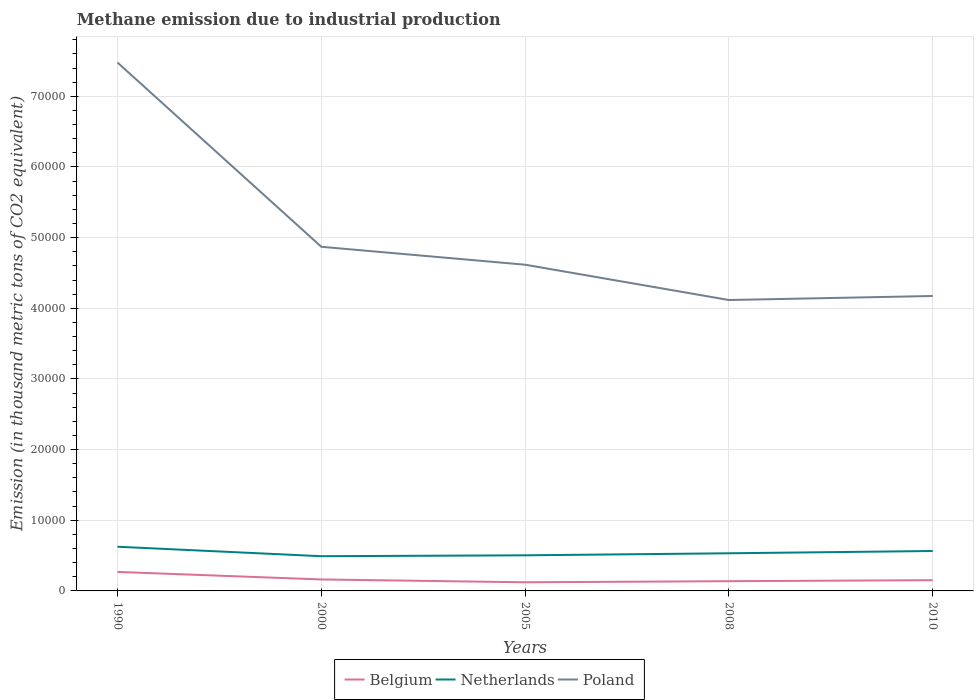How many different coloured lines are there?
Your response must be concise. 3. Does the line corresponding to Poland intersect with the line corresponding to Belgium?
Offer a very short reply. No. Is the number of lines equal to the number of legend labels?
Your answer should be compact. Yes. Across all years, what is the maximum amount of methane emitted in Poland?
Provide a succinct answer. 4.12e+04. What is the total amount of methane emitted in Belgium in the graph?
Make the answer very short. 400.3. What is the difference between the highest and the second highest amount of methane emitted in Belgium?
Make the answer very short. 1465.5. Is the amount of methane emitted in Netherlands strictly greater than the amount of methane emitted in Belgium over the years?
Your answer should be compact. No. How many lines are there?
Your answer should be compact. 3. How many years are there in the graph?
Ensure brevity in your answer.  5. What is the difference between two consecutive major ticks on the Y-axis?
Ensure brevity in your answer.  10000. Are the values on the major ticks of Y-axis written in scientific E-notation?
Offer a terse response. No. Does the graph contain any zero values?
Your answer should be very brief. No. Where does the legend appear in the graph?
Your answer should be very brief. Bottom center. How are the legend labels stacked?
Your answer should be compact. Horizontal. What is the title of the graph?
Make the answer very short. Methane emission due to industrial production. What is the label or title of the X-axis?
Provide a succinct answer. Years. What is the label or title of the Y-axis?
Ensure brevity in your answer.  Emission (in thousand metric tons of CO2 equivalent). What is the Emission (in thousand metric tons of CO2 equivalent) of Belgium in 1990?
Your answer should be very brief. 2688.2. What is the Emission (in thousand metric tons of CO2 equivalent) of Netherlands in 1990?
Your answer should be very brief. 6254.4. What is the Emission (in thousand metric tons of CO2 equivalent) in Poland in 1990?
Your answer should be very brief. 7.48e+04. What is the Emission (in thousand metric tons of CO2 equivalent) of Belgium in 2000?
Give a very brief answer. 1623. What is the Emission (in thousand metric tons of CO2 equivalent) of Netherlands in 2000?
Your answer should be compact. 4913.4. What is the Emission (in thousand metric tons of CO2 equivalent) in Poland in 2000?
Keep it short and to the point. 4.87e+04. What is the Emission (in thousand metric tons of CO2 equivalent) of Belgium in 2005?
Your response must be concise. 1222.7. What is the Emission (in thousand metric tons of CO2 equivalent) of Netherlands in 2005?
Give a very brief answer. 5039.5. What is the Emission (in thousand metric tons of CO2 equivalent) in Poland in 2005?
Offer a terse response. 4.62e+04. What is the Emission (in thousand metric tons of CO2 equivalent) of Belgium in 2008?
Keep it short and to the point. 1376.4. What is the Emission (in thousand metric tons of CO2 equivalent) of Netherlands in 2008?
Your answer should be compact. 5326.8. What is the Emission (in thousand metric tons of CO2 equivalent) of Poland in 2008?
Make the answer very short. 4.12e+04. What is the Emission (in thousand metric tons of CO2 equivalent) in Belgium in 2010?
Your response must be concise. 1518. What is the Emission (in thousand metric tons of CO2 equivalent) of Netherlands in 2010?
Offer a terse response. 5650. What is the Emission (in thousand metric tons of CO2 equivalent) of Poland in 2010?
Keep it short and to the point. 4.17e+04. Across all years, what is the maximum Emission (in thousand metric tons of CO2 equivalent) of Belgium?
Keep it short and to the point. 2688.2. Across all years, what is the maximum Emission (in thousand metric tons of CO2 equivalent) in Netherlands?
Provide a succinct answer. 6254.4. Across all years, what is the maximum Emission (in thousand metric tons of CO2 equivalent) in Poland?
Offer a terse response. 7.48e+04. Across all years, what is the minimum Emission (in thousand metric tons of CO2 equivalent) in Belgium?
Offer a terse response. 1222.7. Across all years, what is the minimum Emission (in thousand metric tons of CO2 equivalent) in Netherlands?
Keep it short and to the point. 4913.4. Across all years, what is the minimum Emission (in thousand metric tons of CO2 equivalent) in Poland?
Make the answer very short. 4.12e+04. What is the total Emission (in thousand metric tons of CO2 equivalent) in Belgium in the graph?
Your answer should be compact. 8428.3. What is the total Emission (in thousand metric tons of CO2 equivalent) in Netherlands in the graph?
Make the answer very short. 2.72e+04. What is the total Emission (in thousand metric tons of CO2 equivalent) of Poland in the graph?
Make the answer very short. 2.53e+05. What is the difference between the Emission (in thousand metric tons of CO2 equivalent) in Belgium in 1990 and that in 2000?
Your answer should be compact. 1065.2. What is the difference between the Emission (in thousand metric tons of CO2 equivalent) of Netherlands in 1990 and that in 2000?
Give a very brief answer. 1341. What is the difference between the Emission (in thousand metric tons of CO2 equivalent) of Poland in 1990 and that in 2000?
Give a very brief answer. 2.61e+04. What is the difference between the Emission (in thousand metric tons of CO2 equivalent) of Belgium in 1990 and that in 2005?
Keep it short and to the point. 1465.5. What is the difference between the Emission (in thousand metric tons of CO2 equivalent) in Netherlands in 1990 and that in 2005?
Ensure brevity in your answer.  1214.9. What is the difference between the Emission (in thousand metric tons of CO2 equivalent) in Poland in 1990 and that in 2005?
Your answer should be compact. 2.86e+04. What is the difference between the Emission (in thousand metric tons of CO2 equivalent) in Belgium in 1990 and that in 2008?
Make the answer very short. 1311.8. What is the difference between the Emission (in thousand metric tons of CO2 equivalent) of Netherlands in 1990 and that in 2008?
Keep it short and to the point. 927.6. What is the difference between the Emission (in thousand metric tons of CO2 equivalent) in Poland in 1990 and that in 2008?
Make the answer very short. 3.36e+04. What is the difference between the Emission (in thousand metric tons of CO2 equivalent) of Belgium in 1990 and that in 2010?
Make the answer very short. 1170.2. What is the difference between the Emission (in thousand metric tons of CO2 equivalent) in Netherlands in 1990 and that in 2010?
Your answer should be compact. 604.4. What is the difference between the Emission (in thousand metric tons of CO2 equivalent) of Poland in 1990 and that in 2010?
Offer a terse response. 3.30e+04. What is the difference between the Emission (in thousand metric tons of CO2 equivalent) in Belgium in 2000 and that in 2005?
Give a very brief answer. 400.3. What is the difference between the Emission (in thousand metric tons of CO2 equivalent) in Netherlands in 2000 and that in 2005?
Keep it short and to the point. -126.1. What is the difference between the Emission (in thousand metric tons of CO2 equivalent) of Poland in 2000 and that in 2005?
Your response must be concise. 2536.5. What is the difference between the Emission (in thousand metric tons of CO2 equivalent) of Belgium in 2000 and that in 2008?
Make the answer very short. 246.6. What is the difference between the Emission (in thousand metric tons of CO2 equivalent) of Netherlands in 2000 and that in 2008?
Your answer should be very brief. -413.4. What is the difference between the Emission (in thousand metric tons of CO2 equivalent) in Poland in 2000 and that in 2008?
Make the answer very short. 7532.6. What is the difference between the Emission (in thousand metric tons of CO2 equivalent) of Belgium in 2000 and that in 2010?
Offer a very short reply. 105. What is the difference between the Emission (in thousand metric tons of CO2 equivalent) in Netherlands in 2000 and that in 2010?
Your answer should be compact. -736.6. What is the difference between the Emission (in thousand metric tons of CO2 equivalent) in Poland in 2000 and that in 2010?
Provide a short and direct response. 6963.4. What is the difference between the Emission (in thousand metric tons of CO2 equivalent) of Belgium in 2005 and that in 2008?
Your answer should be very brief. -153.7. What is the difference between the Emission (in thousand metric tons of CO2 equivalent) in Netherlands in 2005 and that in 2008?
Your answer should be compact. -287.3. What is the difference between the Emission (in thousand metric tons of CO2 equivalent) of Poland in 2005 and that in 2008?
Your answer should be very brief. 4996.1. What is the difference between the Emission (in thousand metric tons of CO2 equivalent) in Belgium in 2005 and that in 2010?
Keep it short and to the point. -295.3. What is the difference between the Emission (in thousand metric tons of CO2 equivalent) in Netherlands in 2005 and that in 2010?
Offer a very short reply. -610.5. What is the difference between the Emission (in thousand metric tons of CO2 equivalent) in Poland in 2005 and that in 2010?
Make the answer very short. 4426.9. What is the difference between the Emission (in thousand metric tons of CO2 equivalent) in Belgium in 2008 and that in 2010?
Provide a succinct answer. -141.6. What is the difference between the Emission (in thousand metric tons of CO2 equivalent) in Netherlands in 2008 and that in 2010?
Offer a terse response. -323.2. What is the difference between the Emission (in thousand metric tons of CO2 equivalent) in Poland in 2008 and that in 2010?
Make the answer very short. -569.2. What is the difference between the Emission (in thousand metric tons of CO2 equivalent) in Belgium in 1990 and the Emission (in thousand metric tons of CO2 equivalent) in Netherlands in 2000?
Provide a succinct answer. -2225.2. What is the difference between the Emission (in thousand metric tons of CO2 equivalent) of Belgium in 1990 and the Emission (in thousand metric tons of CO2 equivalent) of Poland in 2000?
Provide a short and direct response. -4.60e+04. What is the difference between the Emission (in thousand metric tons of CO2 equivalent) in Netherlands in 1990 and the Emission (in thousand metric tons of CO2 equivalent) in Poland in 2000?
Give a very brief answer. -4.24e+04. What is the difference between the Emission (in thousand metric tons of CO2 equivalent) in Belgium in 1990 and the Emission (in thousand metric tons of CO2 equivalent) in Netherlands in 2005?
Offer a terse response. -2351.3. What is the difference between the Emission (in thousand metric tons of CO2 equivalent) in Belgium in 1990 and the Emission (in thousand metric tons of CO2 equivalent) in Poland in 2005?
Ensure brevity in your answer.  -4.35e+04. What is the difference between the Emission (in thousand metric tons of CO2 equivalent) in Netherlands in 1990 and the Emission (in thousand metric tons of CO2 equivalent) in Poland in 2005?
Give a very brief answer. -3.99e+04. What is the difference between the Emission (in thousand metric tons of CO2 equivalent) of Belgium in 1990 and the Emission (in thousand metric tons of CO2 equivalent) of Netherlands in 2008?
Give a very brief answer. -2638.6. What is the difference between the Emission (in thousand metric tons of CO2 equivalent) of Belgium in 1990 and the Emission (in thousand metric tons of CO2 equivalent) of Poland in 2008?
Make the answer very short. -3.85e+04. What is the difference between the Emission (in thousand metric tons of CO2 equivalent) in Netherlands in 1990 and the Emission (in thousand metric tons of CO2 equivalent) in Poland in 2008?
Make the answer very short. -3.49e+04. What is the difference between the Emission (in thousand metric tons of CO2 equivalent) of Belgium in 1990 and the Emission (in thousand metric tons of CO2 equivalent) of Netherlands in 2010?
Your response must be concise. -2961.8. What is the difference between the Emission (in thousand metric tons of CO2 equivalent) in Belgium in 1990 and the Emission (in thousand metric tons of CO2 equivalent) in Poland in 2010?
Keep it short and to the point. -3.90e+04. What is the difference between the Emission (in thousand metric tons of CO2 equivalent) of Netherlands in 1990 and the Emission (in thousand metric tons of CO2 equivalent) of Poland in 2010?
Your answer should be very brief. -3.55e+04. What is the difference between the Emission (in thousand metric tons of CO2 equivalent) of Belgium in 2000 and the Emission (in thousand metric tons of CO2 equivalent) of Netherlands in 2005?
Your response must be concise. -3416.5. What is the difference between the Emission (in thousand metric tons of CO2 equivalent) in Belgium in 2000 and the Emission (in thousand metric tons of CO2 equivalent) in Poland in 2005?
Offer a terse response. -4.45e+04. What is the difference between the Emission (in thousand metric tons of CO2 equivalent) in Netherlands in 2000 and the Emission (in thousand metric tons of CO2 equivalent) in Poland in 2005?
Offer a terse response. -4.13e+04. What is the difference between the Emission (in thousand metric tons of CO2 equivalent) of Belgium in 2000 and the Emission (in thousand metric tons of CO2 equivalent) of Netherlands in 2008?
Offer a very short reply. -3703.8. What is the difference between the Emission (in thousand metric tons of CO2 equivalent) of Belgium in 2000 and the Emission (in thousand metric tons of CO2 equivalent) of Poland in 2008?
Make the answer very short. -3.95e+04. What is the difference between the Emission (in thousand metric tons of CO2 equivalent) in Netherlands in 2000 and the Emission (in thousand metric tons of CO2 equivalent) in Poland in 2008?
Make the answer very short. -3.63e+04. What is the difference between the Emission (in thousand metric tons of CO2 equivalent) in Belgium in 2000 and the Emission (in thousand metric tons of CO2 equivalent) in Netherlands in 2010?
Your answer should be very brief. -4027. What is the difference between the Emission (in thousand metric tons of CO2 equivalent) in Belgium in 2000 and the Emission (in thousand metric tons of CO2 equivalent) in Poland in 2010?
Give a very brief answer. -4.01e+04. What is the difference between the Emission (in thousand metric tons of CO2 equivalent) of Netherlands in 2000 and the Emission (in thousand metric tons of CO2 equivalent) of Poland in 2010?
Provide a succinct answer. -3.68e+04. What is the difference between the Emission (in thousand metric tons of CO2 equivalent) of Belgium in 2005 and the Emission (in thousand metric tons of CO2 equivalent) of Netherlands in 2008?
Provide a short and direct response. -4104.1. What is the difference between the Emission (in thousand metric tons of CO2 equivalent) of Belgium in 2005 and the Emission (in thousand metric tons of CO2 equivalent) of Poland in 2008?
Provide a short and direct response. -3.99e+04. What is the difference between the Emission (in thousand metric tons of CO2 equivalent) of Netherlands in 2005 and the Emission (in thousand metric tons of CO2 equivalent) of Poland in 2008?
Offer a terse response. -3.61e+04. What is the difference between the Emission (in thousand metric tons of CO2 equivalent) in Belgium in 2005 and the Emission (in thousand metric tons of CO2 equivalent) in Netherlands in 2010?
Your response must be concise. -4427.3. What is the difference between the Emission (in thousand metric tons of CO2 equivalent) in Belgium in 2005 and the Emission (in thousand metric tons of CO2 equivalent) in Poland in 2010?
Ensure brevity in your answer.  -4.05e+04. What is the difference between the Emission (in thousand metric tons of CO2 equivalent) in Netherlands in 2005 and the Emission (in thousand metric tons of CO2 equivalent) in Poland in 2010?
Make the answer very short. -3.67e+04. What is the difference between the Emission (in thousand metric tons of CO2 equivalent) of Belgium in 2008 and the Emission (in thousand metric tons of CO2 equivalent) of Netherlands in 2010?
Your answer should be very brief. -4273.6. What is the difference between the Emission (in thousand metric tons of CO2 equivalent) of Belgium in 2008 and the Emission (in thousand metric tons of CO2 equivalent) of Poland in 2010?
Offer a very short reply. -4.04e+04. What is the difference between the Emission (in thousand metric tons of CO2 equivalent) in Netherlands in 2008 and the Emission (in thousand metric tons of CO2 equivalent) in Poland in 2010?
Your response must be concise. -3.64e+04. What is the average Emission (in thousand metric tons of CO2 equivalent) in Belgium per year?
Offer a terse response. 1685.66. What is the average Emission (in thousand metric tons of CO2 equivalent) in Netherlands per year?
Provide a succinct answer. 5436.82. What is the average Emission (in thousand metric tons of CO2 equivalent) in Poland per year?
Your answer should be compact. 5.05e+04. In the year 1990, what is the difference between the Emission (in thousand metric tons of CO2 equivalent) of Belgium and Emission (in thousand metric tons of CO2 equivalent) of Netherlands?
Give a very brief answer. -3566.2. In the year 1990, what is the difference between the Emission (in thousand metric tons of CO2 equivalent) in Belgium and Emission (in thousand metric tons of CO2 equivalent) in Poland?
Provide a short and direct response. -7.21e+04. In the year 1990, what is the difference between the Emission (in thousand metric tons of CO2 equivalent) in Netherlands and Emission (in thousand metric tons of CO2 equivalent) in Poland?
Your answer should be very brief. -6.85e+04. In the year 2000, what is the difference between the Emission (in thousand metric tons of CO2 equivalent) in Belgium and Emission (in thousand metric tons of CO2 equivalent) in Netherlands?
Provide a short and direct response. -3290.4. In the year 2000, what is the difference between the Emission (in thousand metric tons of CO2 equivalent) in Belgium and Emission (in thousand metric tons of CO2 equivalent) in Poland?
Your answer should be compact. -4.71e+04. In the year 2000, what is the difference between the Emission (in thousand metric tons of CO2 equivalent) of Netherlands and Emission (in thousand metric tons of CO2 equivalent) of Poland?
Ensure brevity in your answer.  -4.38e+04. In the year 2005, what is the difference between the Emission (in thousand metric tons of CO2 equivalent) of Belgium and Emission (in thousand metric tons of CO2 equivalent) of Netherlands?
Ensure brevity in your answer.  -3816.8. In the year 2005, what is the difference between the Emission (in thousand metric tons of CO2 equivalent) of Belgium and Emission (in thousand metric tons of CO2 equivalent) of Poland?
Keep it short and to the point. -4.49e+04. In the year 2005, what is the difference between the Emission (in thousand metric tons of CO2 equivalent) of Netherlands and Emission (in thousand metric tons of CO2 equivalent) of Poland?
Your answer should be compact. -4.11e+04. In the year 2008, what is the difference between the Emission (in thousand metric tons of CO2 equivalent) of Belgium and Emission (in thousand metric tons of CO2 equivalent) of Netherlands?
Offer a terse response. -3950.4. In the year 2008, what is the difference between the Emission (in thousand metric tons of CO2 equivalent) of Belgium and Emission (in thousand metric tons of CO2 equivalent) of Poland?
Offer a very short reply. -3.98e+04. In the year 2008, what is the difference between the Emission (in thousand metric tons of CO2 equivalent) in Netherlands and Emission (in thousand metric tons of CO2 equivalent) in Poland?
Your answer should be very brief. -3.58e+04. In the year 2010, what is the difference between the Emission (in thousand metric tons of CO2 equivalent) in Belgium and Emission (in thousand metric tons of CO2 equivalent) in Netherlands?
Keep it short and to the point. -4132. In the year 2010, what is the difference between the Emission (in thousand metric tons of CO2 equivalent) of Belgium and Emission (in thousand metric tons of CO2 equivalent) of Poland?
Ensure brevity in your answer.  -4.02e+04. In the year 2010, what is the difference between the Emission (in thousand metric tons of CO2 equivalent) of Netherlands and Emission (in thousand metric tons of CO2 equivalent) of Poland?
Make the answer very short. -3.61e+04. What is the ratio of the Emission (in thousand metric tons of CO2 equivalent) in Belgium in 1990 to that in 2000?
Provide a short and direct response. 1.66. What is the ratio of the Emission (in thousand metric tons of CO2 equivalent) of Netherlands in 1990 to that in 2000?
Ensure brevity in your answer.  1.27. What is the ratio of the Emission (in thousand metric tons of CO2 equivalent) in Poland in 1990 to that in 2000?
Your answer should be very brief. 1.54. What is the ratio of the Emission (in thousand metric tons of CO2 equivalent) of Belgium in 1990 to that in 2005?
Provide a short and direct response. 2.2. What is the ratio of the Emission (in thousand metric tons of CO2 equivalent) of Netherlands in 1990 to that in 2005?
Give a very brief answer. 1.24. What is the ratio of the Emission (in thousand metric tons of CO2 equivalent) of Poland in 1990 to that in 2005?
Offer a very short reply. 1.62. What is the ratio of the Emission (in thousand metric tons of CO2 equivalent) in Belgium in 1990 to that in 2008?
Your answer should be compact. 1.95. What is the ratio of the Emission (in thousand metric tons of CO2 equivalent) in Netherlands in 1990 to that in 2008?
Your answer should be compact. 1.17. What is the ratio of the Emission (in thousand metric tons of CO2 equivalent) in Poland in 1990 to that in 2008?
Give a very brief answer. 1.82. What is the ratio of the Emission (in thousand metric tons of CO2 equivalent) of Belgium in 1990 to that in 2010?
Your response must be concise. 1.77. What is the ratio of the Emission (in thousand metric tons of CO2 equivalent) of Netherlands in 1990 to that in 2010?
Offer a very short reply. 1.11. What is the ratio of the Emission (in thousand metric tons of CO2 equivalent) in Poland in 1990 to that in 2010?
Your answer should be very brief. 1.79. What is the ratio of the Emission (in thousand metric tons of CO2 equivalent) in Belgium in 2000 to that in 2005?
Provide a short and direct response. 1.33. What is the ratio of the Emission (in thousand metric tons of CO2 equivalent) in Netherlands in 2000 to that in 2005?
Your answer should be compact. 0.97. What is the ratio of the Emission (in thousand metric tons of CO2 equivalent) in Poland in 2000 to that in 2005?
Provide a succinct answer. 1.05. What is the ratio of the Emission (in thousand metric tons of CO2 equivalent) in Belgium in 2000 to that in 2008?
Provide a succinct answer. 1.18. What is the ratio of the Emission (in thousand metric tons of CO2 equivalent) of Netherlands in 2000 to that in 2008?
Keep it short and to the point. 0.92. What is the ratio of the Emission (in thousand metric tons of CO2 equivalent) of Poland in 2000 to that in 2008?
Keep it short and to the point. 1.18. What is the ratio of the Emission (in thousand metric tons of CO2 equivalent) in Belgium in 2000 to that in 2010?
Offer a very short reply. 1.07. What is the ratio of the Emission (in thousand metric tons of CO2 equivalent) of Netherlands in 2000 to that in 2010?
Make the answer very short. 0.87. What is the ratio of the Emission (in thousand metric tons of CO2 equivalent) in Poland in 2000 to that in 2010?
Provide a succinct answer. 1.17. What is the ratio of the Emission (in thousand metric tons of CO2 equivalent) of Belgium in 2005 to that in 2008?
Keep it short and to the point. 0.89. What is the ratio of the Emission (in thousand metric tons of CO2 equivalent) of Netherlands in 2005 to that in 2008?
Your response must be concise. 0.95. What is the ratio of the Emission (in thousand metric tons of CO2 equivalent) in Poland in 2005 to that in 2008?
Offer a terse response. 1.12. What is the ratio of the Emission (in thousand metric tons of CO2 equivalent) in Belgium in 2005 to that in 2010?
Provide a short and direct response. 0.81. What is the ratio of the Emission (in thousand metric tons of CO2 equivalent) in Netherlands in 2005 to that in 2010?
Provide a short and direct response. 0.89. What is the ratio of the Emission (in thousand metric tons of CO2 equivalent) in Poland in 2005 to that in 2010?
Ensure brevity in your answer.  1.11. What is the ratio of the Emission (in thousand metric tons of CO2 equivalent) of Belgium in 2008 to that in 2010?
Make the answer very short. 0.91. What is the ratio of the Emission (in thousand metric tons of CO2 equivalent) of Netherlands in 2008 to that in 2010?
Your response must be concise. 0.94. What is the ratio of the Emission (in thousand metric tons of CO2 equivalent) in Poland in 2008 to that in 2010?
Give a very brief answer. 0.99. What is the difference between the highest and the second highest Emission (in thousand metric tons of CO2 equivalent) of Belgium?
Make the answer very short. 1065.2. What is the difference between the highest and the second highest Emission (in thousand metric tons of CO2 equivalent) of Netherlands?
Provide a succinct answer. 604.4. What is the difference between the highest and the second highest Emission (in thousand metric tons of CO2 equivalent) in Poland?
Give a very brief answer. 2.61e+04. What is the difference between the highest and the lowest Emission (in thousand metric tons of CO2 equivalent) of Belgium?
Ensure brevity in your answer.  1465.5. What is the difference between the highest and the lowest Emission (in thousand metric tons of CO2 equivalent) of Netherlands?
Your answer should be compact. 1341. What is the difference between the highest and the lowest Emission (in thousand metric tons of CO2 equivalent) of Poland?
Your answer should be very brief. 3.36e+04. 